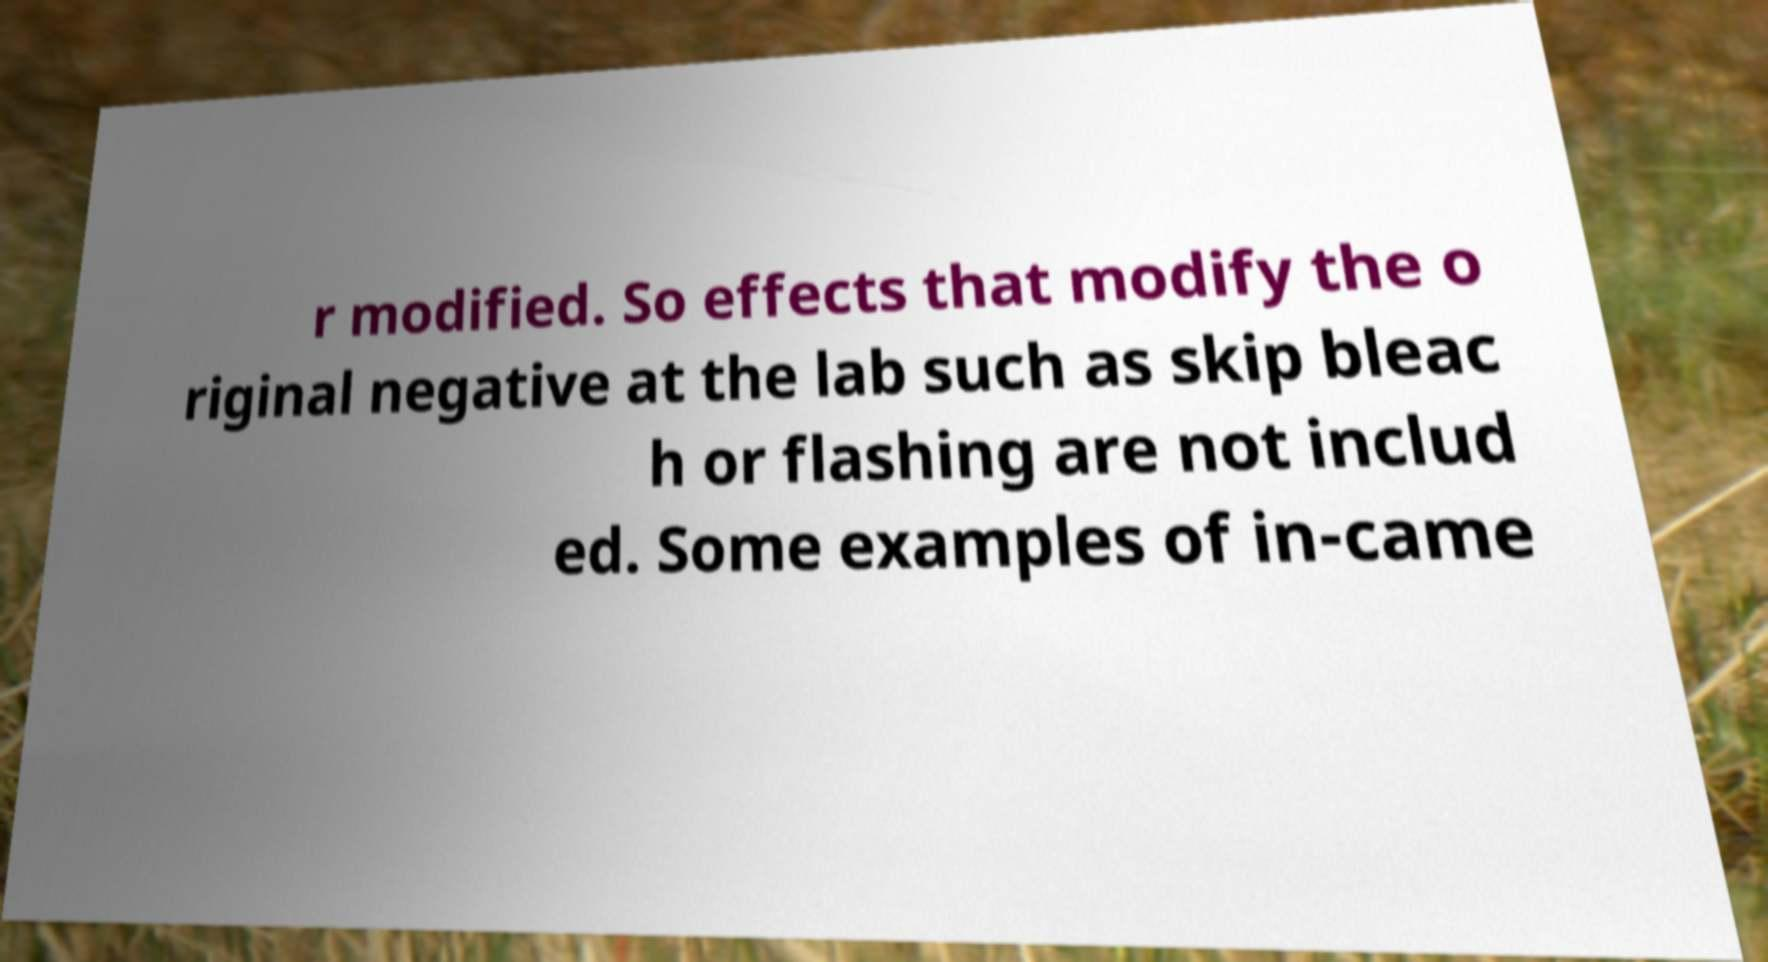For documentation purposes, I need the text within this image transcribed. Could you provide that? r modified. So effects that modify the o riginal negative at the lab such as skip bleac h or flashing are not includ ed. Some examples of in-came 